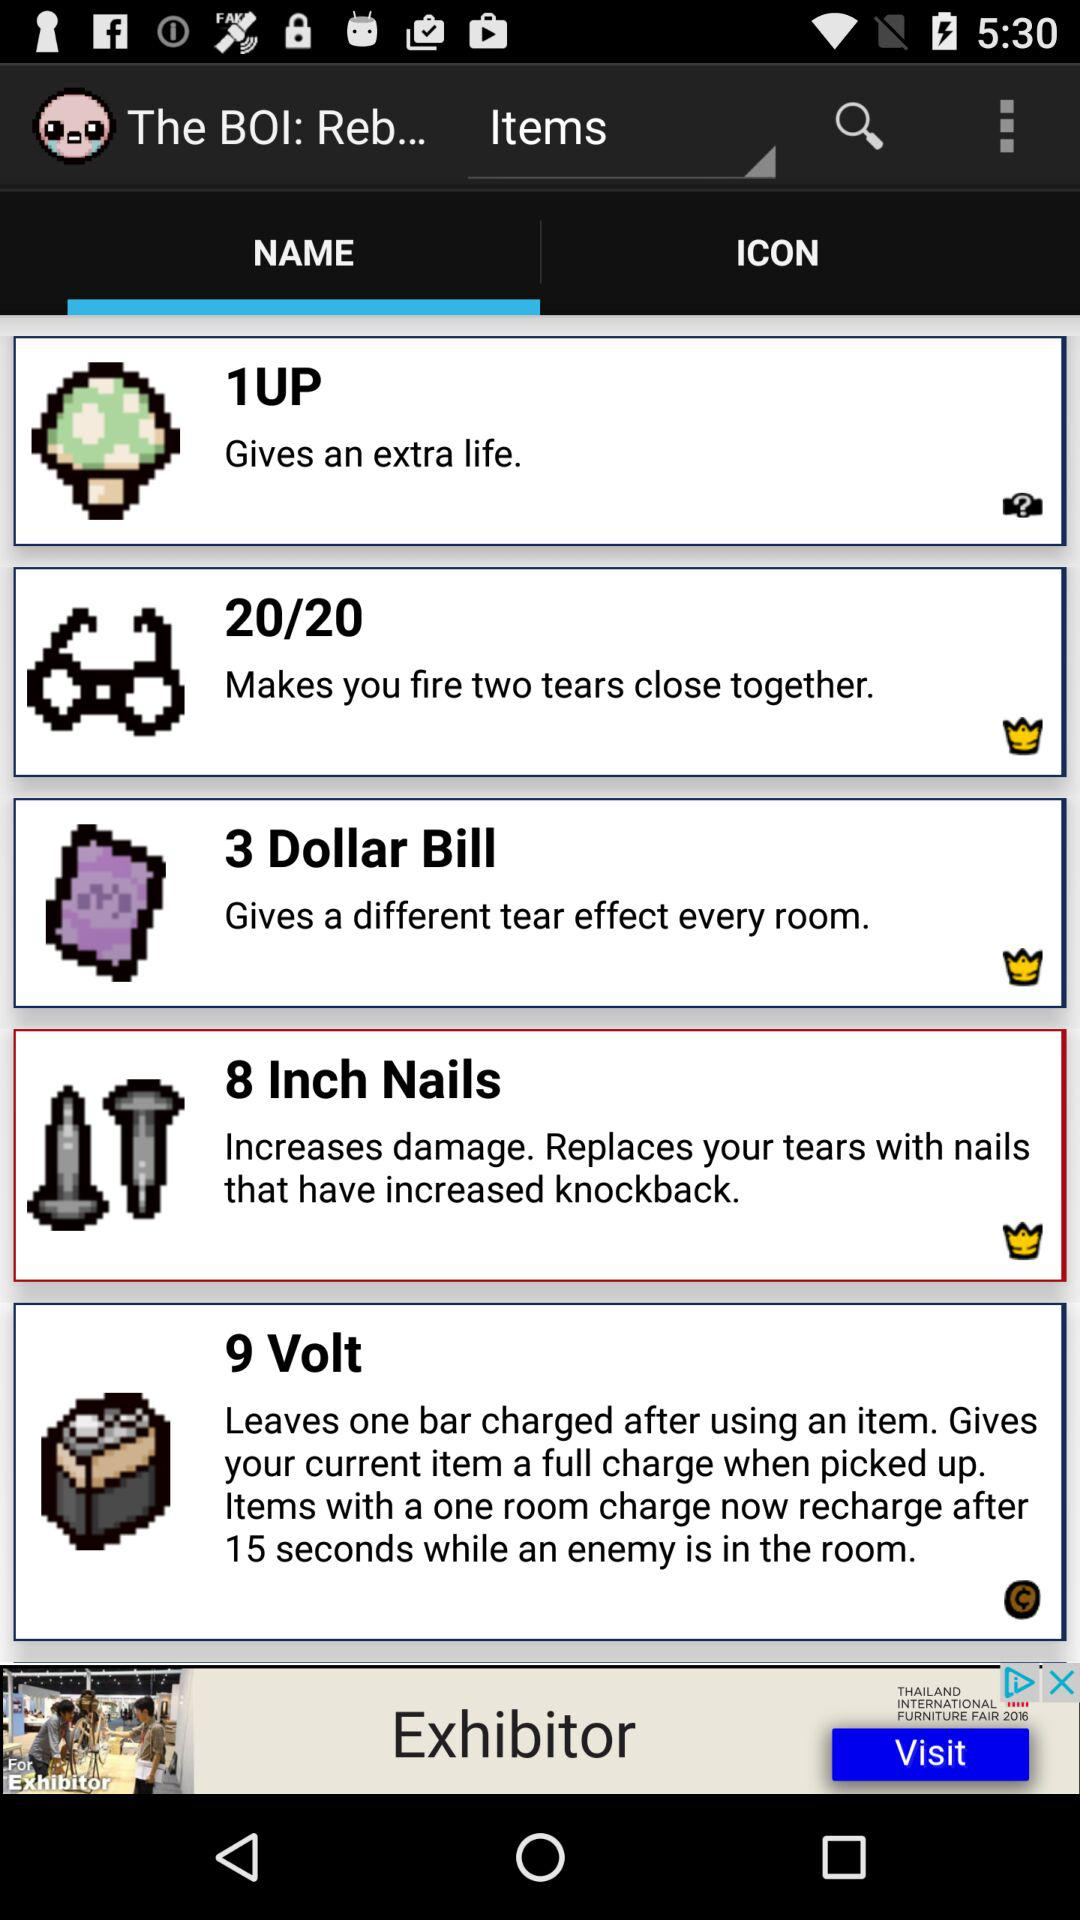What is the size of a nail? The size is 8 inches. 